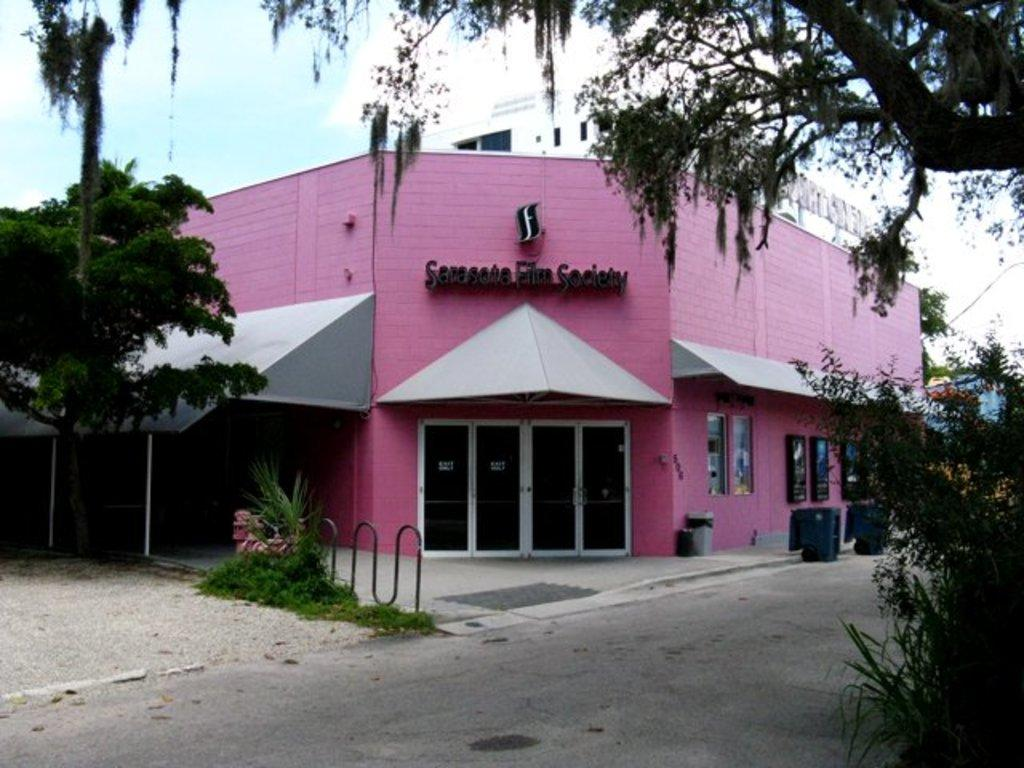What type of structures can be seen in the image? There are buildings in the image. What natural elements are present in the image? There are trees and grass in the image. What architectural features can be observed in the image? There are doors in the image. What additional objects are visible in the image? There are boards in the image. What can be seen in the background of the image? The sky is visible in the background of the image. What type of curtain is hanging in the hospital room in the image? There is no hospital or curtain present in the image. How is the division between the buildings in the image achieved? The image does not show any divisions between the buildings; it only shows the buildings themselves. 